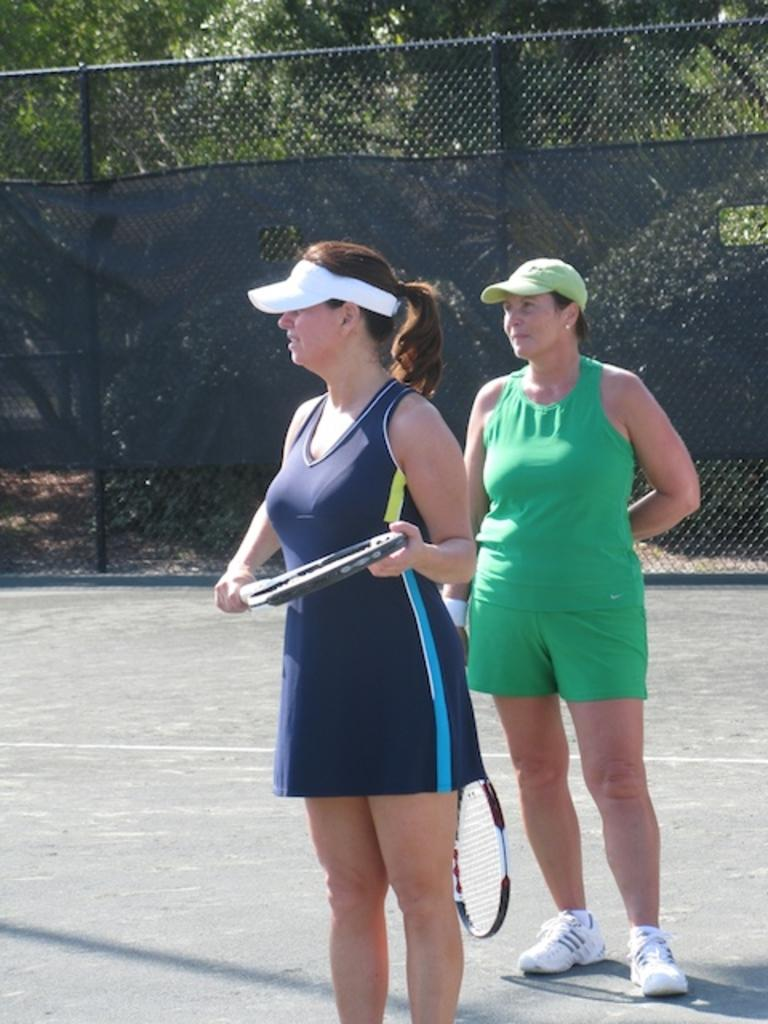How many people are in the image? There are two women in the image. What are the women doing in the image? The women are standing and holding tennis rackets. What can be seen in the background of the image? There is a net visible in the image. What color are the aunt's shoes in the image? There is no mention of an aunt or shoes in the image, so we cannot answer this question. 